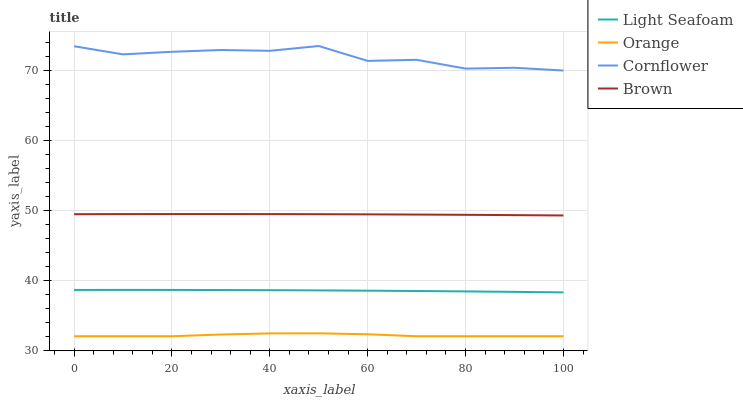Does Orange have the minimum area under the curve?
Answer yes or no. Yes. Does Cornflower have the maximum area under the curve?
Answer yes or no. Yes. Does Light Seafoam have the minimum area under the curve?
Answer yes or no. No. Does Light Seafoam have the maximum area under the curve?
Answer yes or no. No. Is Brown the smoothest?
Answer yes or no. Yes. Is Cornflower the roughest?
Answer yes or no. Yes. Is Light Seafoam the smoothest?
Answer yes or no. No. Is Light Seafoam the roughest?
Answer yes or no. No. Does Orange have the lowest value?
Answer yes or no. Yes. Does Light Seafoam have the lowest value?
Answer yes or no. No. Does Cornflower have the highest value?
Answer yes or no. Yes. Does Light Seafoam have the highest value?
Answer yes or no. No. Is Light Seafoam less than Brown?
Answer yes or no. Yes. Is Cornflower greater than Light Seafoam?
Answer yes or no. Yes. Does Light Seafoam intersect Brown?
Answer yes or no. No. 